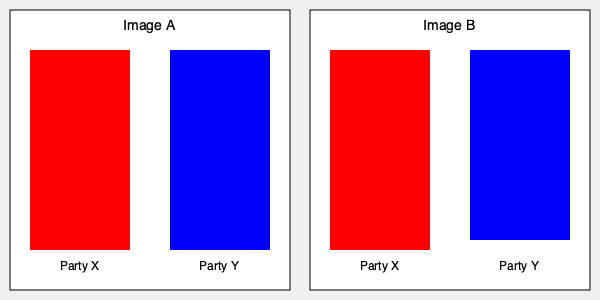In the context of political campaign infographics, what is the key difference between Image A and Image B, and how might this subtle change influence voters' perceptions of the parties' relative strengths? To identify the difference between the two infographics and understand its potential impact on voters' perceptions, let's analyze the images step-by-step:

1. Overall layout: Both images have a similar structure with two vertical bars representing Party X (red) and Party Y (blue).

2. Image A:
   - The red bar (Party X) extends from y=50 to y=250, height = 200 units
   - The blue bar (Party Y) extends from y=50 to y=250, height = 200 units
   - Both bars are equal in height

3. Image B:
   - The red bar (Party X) extends from y=50 to y=250, height = 200 units (unchanged)
   - The blue bar (Party Y) extends from y=50 to y=240, height = 190 units
   - The blue bar is slightly shorter than the red bar

4. Key difference: In Image B, the blue bar (Party Y) is 10 units shorter than in Image A, while the red bar (Party X) remains the same.

5. Potential influence on voters' perceptions:
   - The subtle reduction in the blue bar's height in Image B creates a visual impression that Party Y is slightly less strong or popular than Party X.
   - This small change might subconsciously influence viewers to perceive Party X as having a slight advantage over Party Y.
   - The difference is subtle enough that it might not be immediately noticeable, potentially making it more effective in shaping perceptions without appearing overtly biased.

6. Relevance to language ideologies in political campaigns:
   - This visual representation demonstrates how non-verbal communication (in this case, graphical representation) can be used to convey political messages and potentially influence voters' perceptions.
   - The subtle manipulation of data visualization highlights the importance of critical analysis of campaign materials and the need for voters to be aware of how visual language can be used to shape political narratives.
Answer: Image B shows Party Y's bar slightly shorter, subtly suggesting Party X's advantage. 